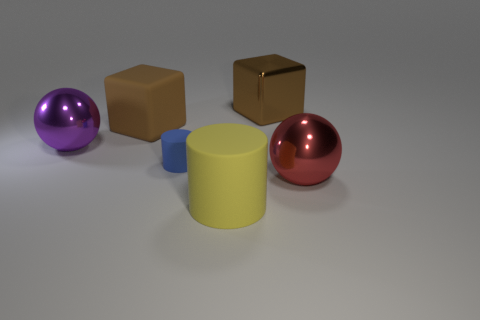Are there any big purple metal objects of the same shape as the big red thing?
Offer a very short reply. Yes. Does the large purple shiny object have the same shape as the metallic thing in front of the purple metallic ball?
Offer a terse response. Yes. Is the number of large brown metallic cubes behind the brown rubber thing less than the number of big spheres that are in front of the brown shiny cube?
Your response must be concise. Yes. There is a small thing that is in front of the large matte object behind the yellow rubber cylinder; what shape is it?
Give a very brief answer. Cylinder. Are there any big shiny cubes?
Your answer should be very brief. Yes. There is a big metallic object right of the big brown metal cube; what color is it?
Offer a very short reply. Red. What is the material of the other block that is the same color as the rubber block?
Keep it short and to the point. Metal. There is a yellow cylinder; are there any large purple balls to the left of it?
Your response must be concise. Yes. Are there more big brown rubber objects than tiny red cubes?
Offer a terse response. Yes. What is the color of the big matte object in front of the brown cube that is in front of the big metallic object behind the purple metallic thing?
Keep it short and to the point. Yellow. 